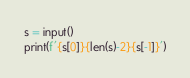<code> <loc_0><loc_0><loc_500><loc_500><_Python_>s = input()
print(f'{s[0]}{len(s)-2}{s[-1]}')</code> 